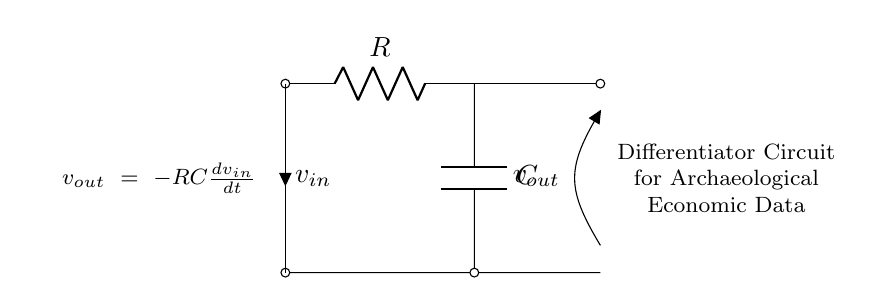What are the components in this circuit? The circuit consists of a resistor and a capacitor, as indicated by the labels R and C.
Answer: Resistor, Capacitor What does the output voltage represent? The output voltage represents the rate of change of the input voltage multiplied by the negative product of the resistance and capacitance, as shown in the equation.
Answer: Rate of change What is the relationship between input and output voltage? The output voltage is inversely proportional to the rate of change of the input voltage; if the input voltage changes rapidly, the output will be a larger negative value due to the negative sign in the equation.
Answer: Inverse proportionality How can you determine the order of the circuit? This is a first-order circuit because it contains one resistor and one capacitor, which classify it as a first-order dynamic system according to the number of energy storage elements.
Answer: First-order What is the function of the capacitor in this circuit? The capacitor acts to differentiate the input voltage signal, meaning it converts changes in voltage over time into a proportional output voltage.
Answer: Differentiate signal What is the output voltage when the input voltage is constant? When the input voltage is constant, there is no change, hence the derivative is zero, leading to an output voltage of zero.
Answer: Zero What are the implications of using a differentiator circuit in analyzing archaeological economic data? Using a differentiator circuit helps in identifying sudden changes or trends in economic data, which can illustrate rapid shifts in economic conditions related to trade or other activities without misinterpreting background noise.
Answer: Analyze changes 